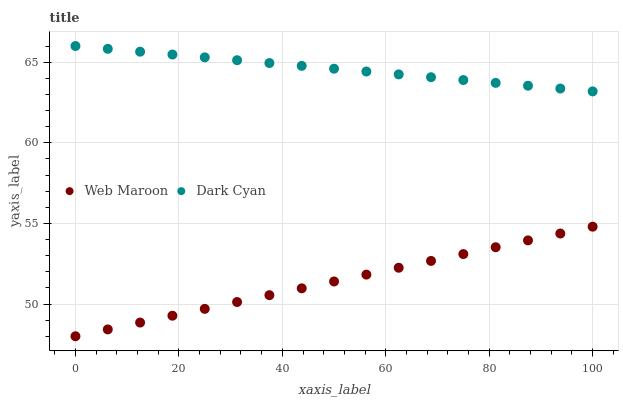Does Web Maroon have the minimum area under the curve?
Answer yes or no. Yes. Does Dark Cyan have the maximum area under the curve?
Answer yes or no. Yes. Does Web Maroon have the maximum area under the curve?
Answer yes or no. No. Is Web Maroon the smoothest?
Answer yes or no. Yes. Is Dark Cyan the roughest?
Answer yes or no. Yes. Is Web Maroon the roughest?
Answer yes or no. No. Does Web Maroon have the lowest value?
Answer yes or no. Yes. Does Dark Cyan have the highest value?
Answer yes or no. Yes. Does Web Maroon have the highest value?
Answer yes or no. No. Is Web Maroon less than Dark Cyan?
Answer yes or no. Yes. Is Dark Cyan greater than Web Maroon?
Answer yes or no. Yes. Does Web Maroon intersect Dark Cyan?
Answer yes or no. No. 